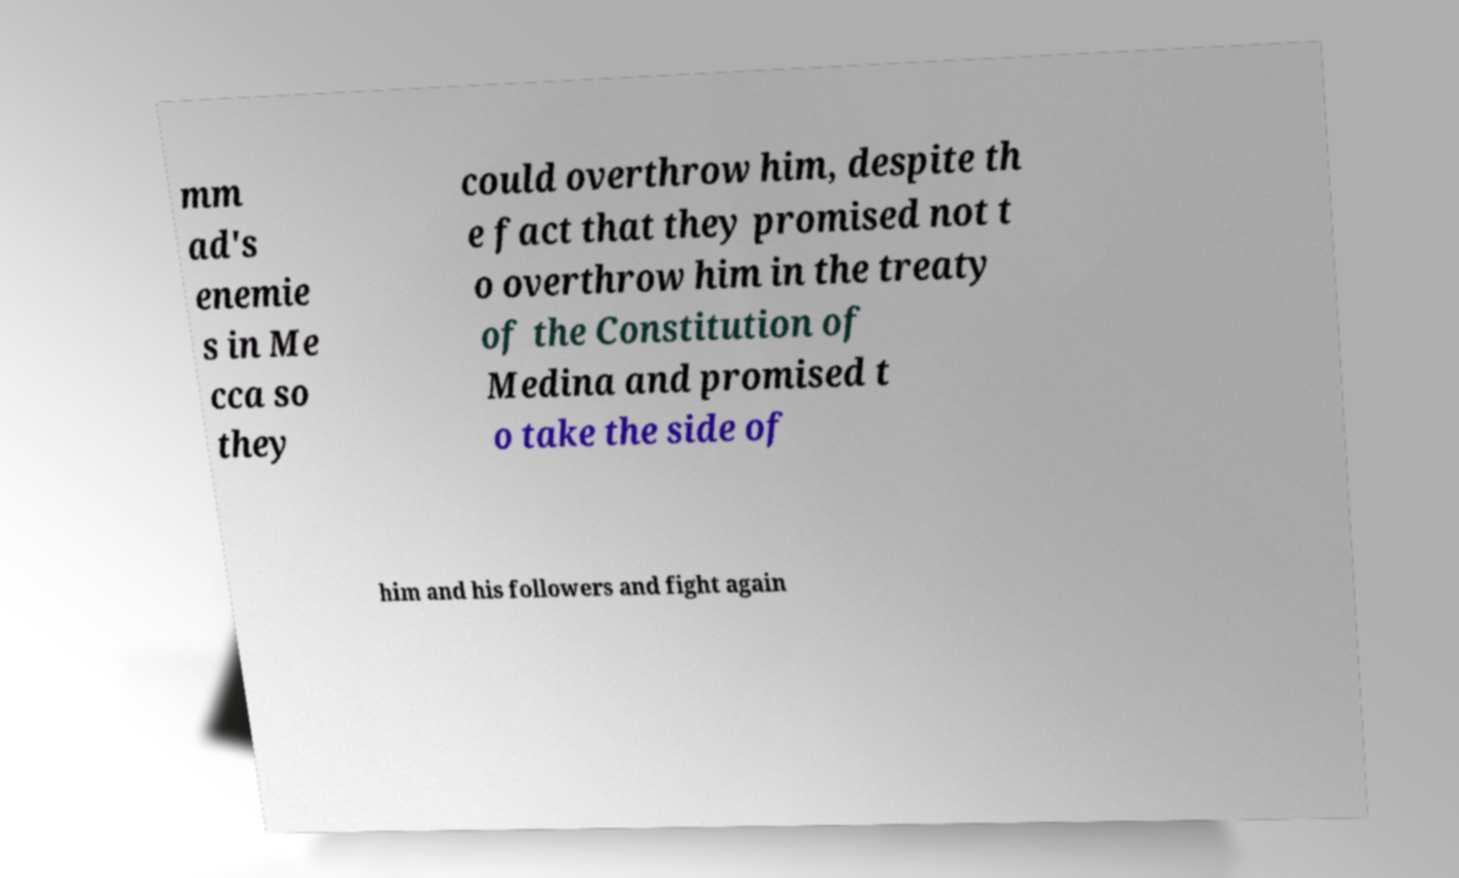Could you assist in decoding the text presented in this image and type it out clearly? mm ad's enemie s in Me cca so they could overthrow him, despite th e fact that they promised not t o overthrow him in the treaty of the Constitution of Medina and promised t o take the side of him and his followers and fight again 